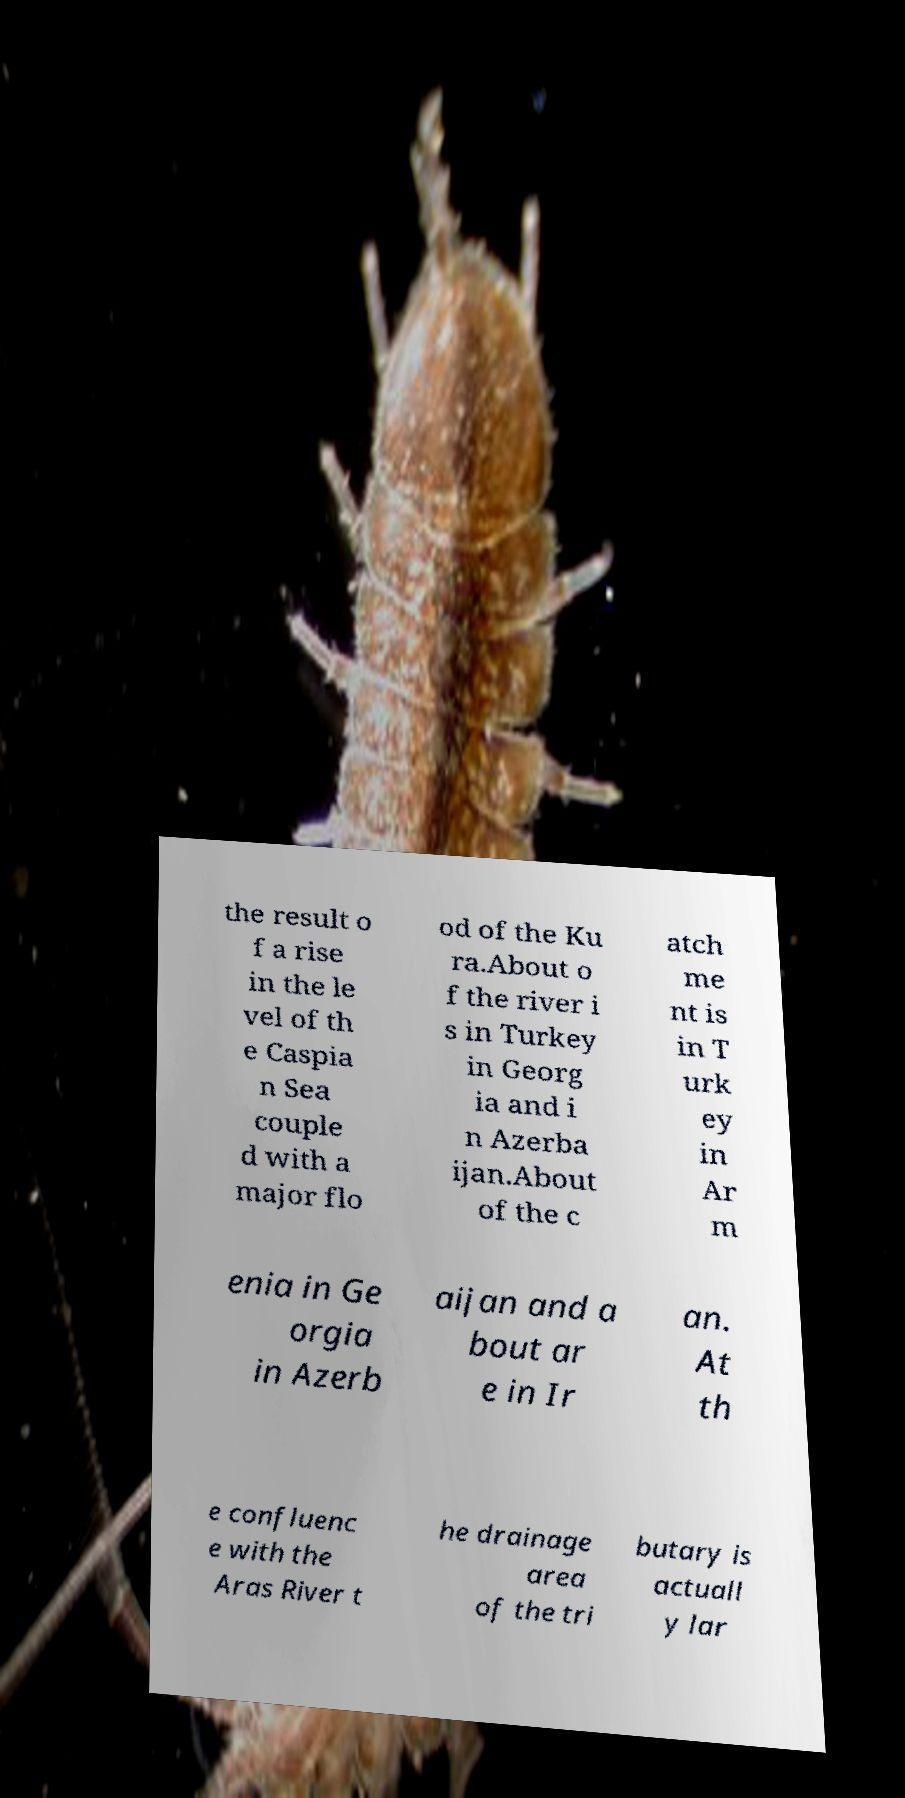Could you assist in decoding the text presented in this image and type it out clearly? the result o f a rise in the le vel of th e Caspia n Sea couple d with a major flo od of the Ku ra.About o f the river i s in Turkey in Georg ia and i n Azerba ijan.About of the c atch me nt is in T urk ey in Ar m enia in Ge orgia in Azerb aijan and a bout ar e in Ir an. At th e confluenc e with the Aras River t he drainage area of the tri butary is actuall y lar 